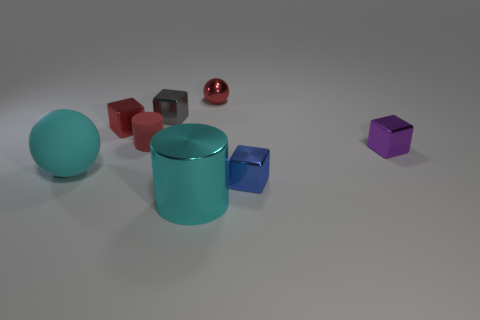There is a cyan object that is in front of the cyan object that is behind the blue metal cube; how big is it?
Make the answer very short. Large. Is there a large shiny thing that has the same color as the tiny sphere?
Offer a very short reply. No. Do the block on the left side of the small rubber object and the matte object that is behind the purple shiny object have the same color?
Your response must be concise. Yes. The small purple object has what shape?
Provide a short and direct response. Cube. What number of red objects are to the left of the large metallic object?
Keep it short and to the point. 2. How many tiny red balls are made of the same material as the tiny cylinder?
Your answer should be compact. 0. Does the cylinder in front of the purple shiny block have the same material as the blue object?
Your answer should be very brief. Yes. Are any small green shiny blocks visible?
Provide a succinct answer. No. How big is the red thing that is both in front of the gray cube and right of the red metallic cube?
Keep it short and to the point. Small. Is the number of tiny red matte objects to the left of the red metal block greater than the number of small balls in front of the tiny gray block?
Make the answer very short. No. 